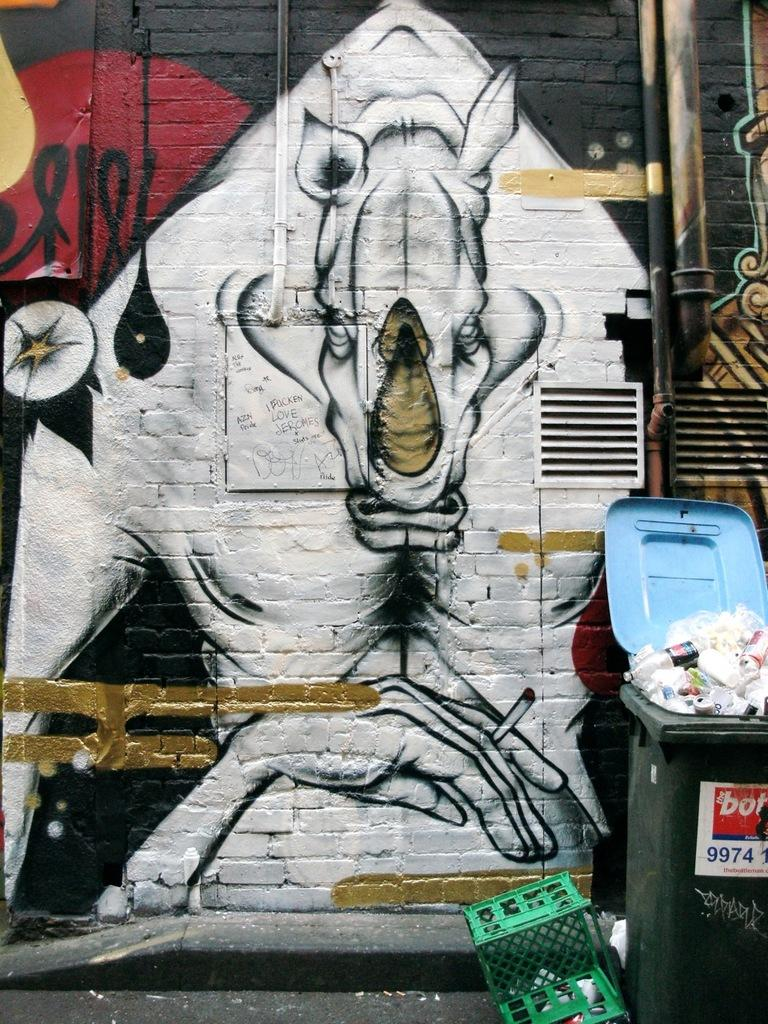<image>
Create a compact narrative representing the image presented. the numbers 9974 are on the front of a trash can 